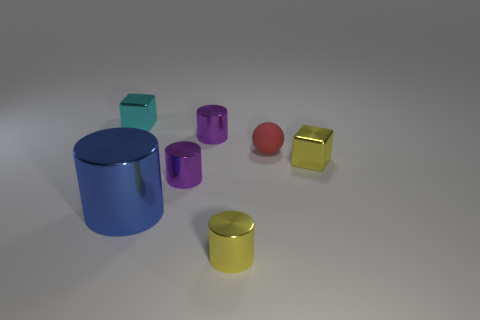The big shiny thing is what color?
Provide a short and direct response. Blue. Are there any yellow things that are on the left side of the tiny yellow metal object right of the yellow cylinder?
Ensure brevity in your answer.  Yes. Are there fewer tiny purple shiny cylinders that are in front of the large blue metallic cylinder than purple matte cylinders?
Keep it short and to the point. No. Are the tiny cube on the left side of the tiny yellow cylinder and the sphere made of the same material?
Keep it short and to the point. No. What color is the other block that is the same material as the tiny cyan block?
Your answer should be compact. Yellow. Is the number of small yellow cylinders that are on the left side of the small cyan block less than the number of large blue things that are behind the small yellow shiny cylinder?
Provide a short and direct response. Yes. Do the small cylinder that is in front of the large blue cylinder and the tiny block on the right side of the blue metallic cylinder have the same color?
Your answer should be very brief. Yes. Are there any small cyan things made of the same material as the blue cylinder?
Offer a very short reply. Yes. There is a cylinder on the left side of the purple metallic object in front of the matte sphere; what is its size?
Give a very brief answer. Large. Are there more big metal objects than gray balls?
Keep it short and to the point. Yes. 